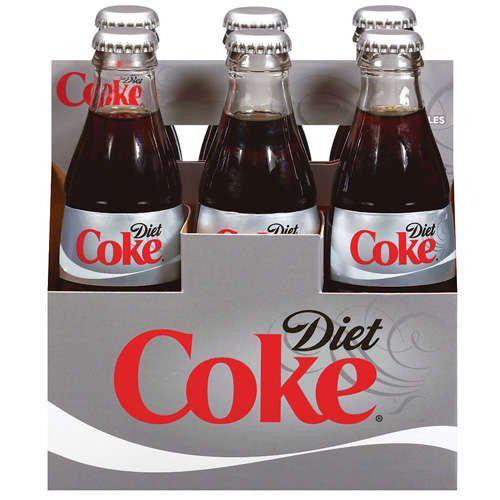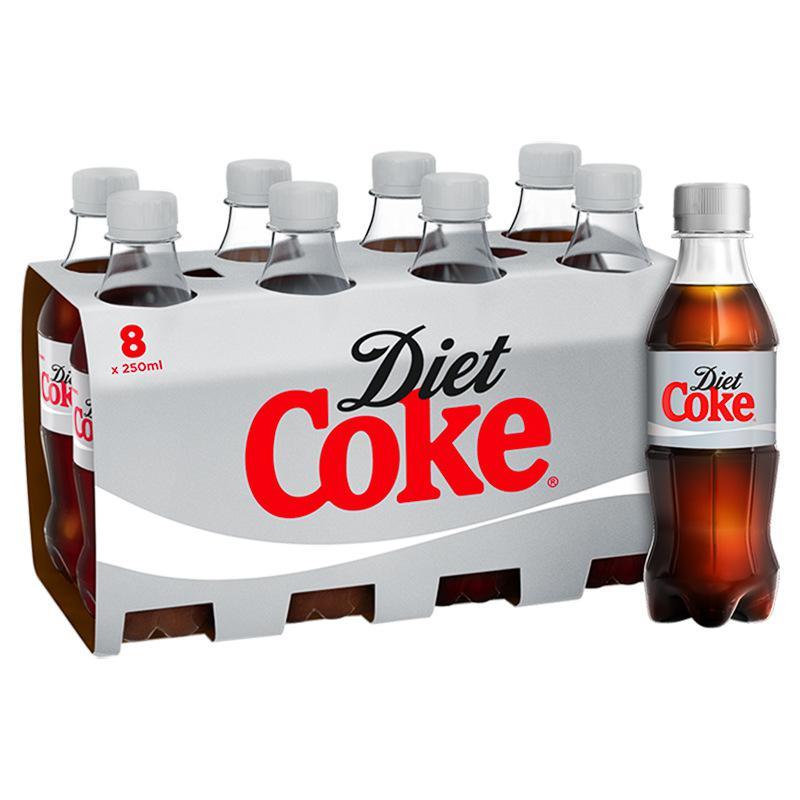The first image is the image on the left, the second image is the image on the right. Evaluate the accuracy of this statement regarding the images: "Each image shows a multipack of eight soda bottles with non-black caps and no box packaging, and the labels of the bottles in the right and left images are nearly identical.". Is it true? Answer yes or no. No. The first image is the image on the left, the second image is the image on the right. For the images shown, is this caption "There are only eight bottles of diet coke in the image to the right; there are no extra, loose bottles." true? Answer yes or no. No. 